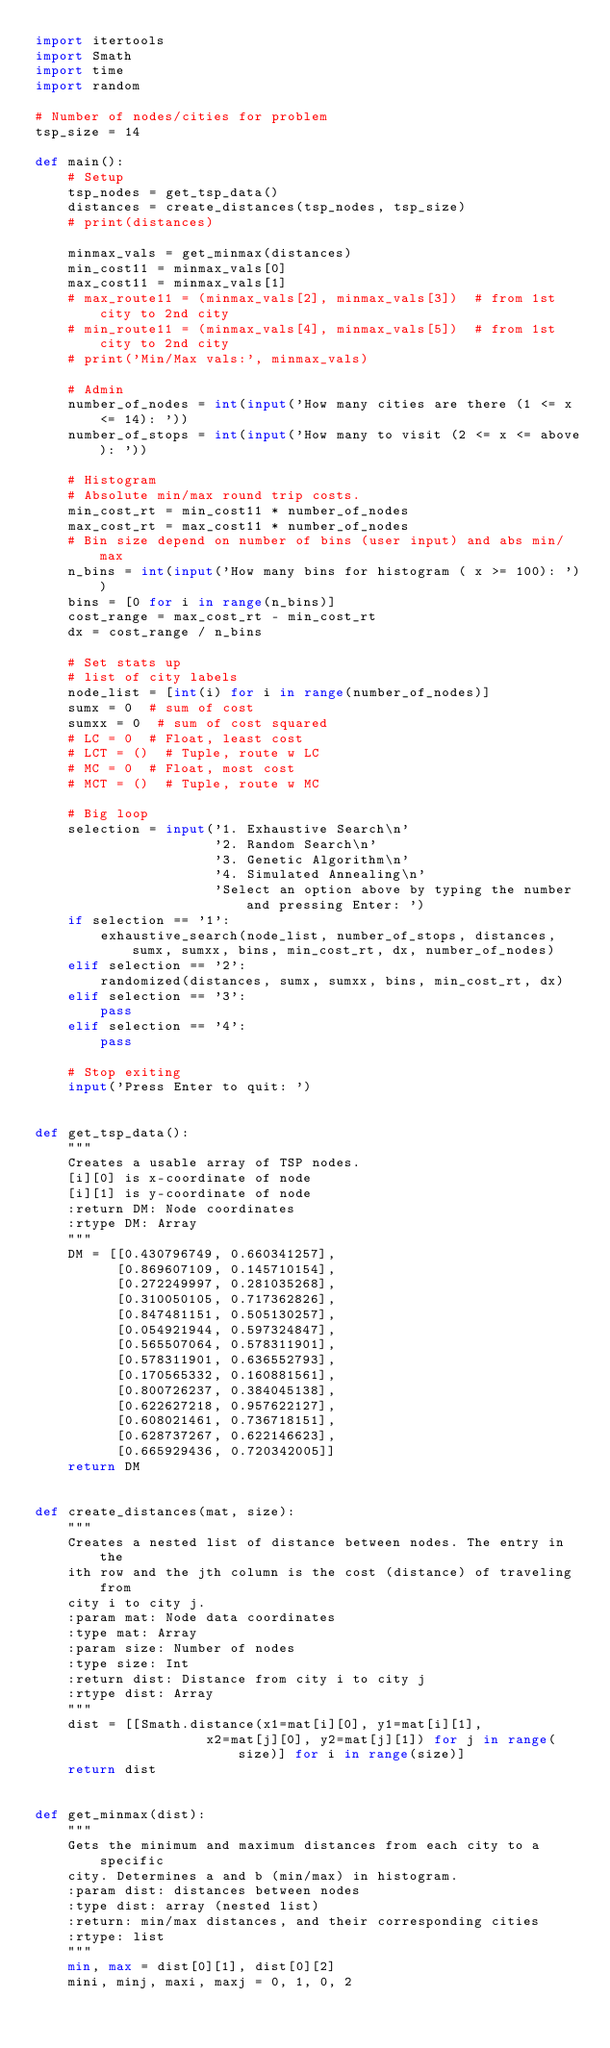Convert code to text. <code><loc_0><loc_0><loc_500><loc_500><_Python_>import itertools
import Smath
import time
import random

# Number of nodes/cities for problem
tsp_size = 14

def main():
    # Setup
    tsp_nodes = get_tsp_data()
    distances = create_distances(tsp_nodes, tsp_size)
    # print(distances)

    minmax_vals = get_minmax(distances)
    min_cost11 = minmax_vals[0]
    max_cost11 = minmax_vals[1]
    # max_route11 = (minmax_vals[2], minmax_vals[3])  # from 1st city to 2nd city
    # min_route11 = (minmax_vals[4], minmax_vals[5])  # from 1st city to 2nd city
    # print('Min/Max vals:', minmax_vals)

    # Admin
    number_of_nodes = int(input('How many cities are there (1 <= x <= 14): '))
    number_of_stops = int(input('How many to visit (2 <= x <= above): '))

    # Histogram
    # Absolute min/max round trip costs.
    min_cost_rt = min_cost11 * number_of_nodes
    max_cost_rt = max_cost11 * number_of_nodes
    # Bin size depend on number of bins (user input) and abs min/max
    n_bins = int(input('How many bins for histogram ( x >= 100): '))
    bins = [0 for i in range(n_bins)]
    cost_range = max_cost_rt - min_cost_rt
    dx = cost_range / n_bins

    # Set stats up
    # list of city labels
    node_list = [int(i) for i in range(number_of_nodes)]
    sumx = 0  # sum of cost
    sumxx = 0  # sum of cost squared
    # LC = 0  # Float, least cost
    # LCT = ()  # Tuple, route w LC
    # MC = 0  # Float, most cost
    # MCT = ()  # Tuple, route w MC

    # Big loop
    selection = input('1. Exhaustive Search\n'
                      '2. Random Search\n'
                      '3. Genetic Algorithm\n'
                      '4. Simulated Annealing\n'
                      'Select an option above by typing the number and pressing Enter: ')
    if selection == '1':
        exhaustive_search(node_list, number_of_stops, distances, sumx, sumxx, bins, min_cost_rt, dx, number_of_nodes)
    elif selection == '2':
        randomized(distances, sumx, sumxx, bins, min_cost_rt, dx)
    elif selection == '3':
        pass
    elif selection == '4':
        pass

    # Stop exiting
    input('Press Enter to quit: ')


def get_tsp_data():
    """
    Creates a usable array of TSP nodes.
    [i][0] is x-coordinate of node
    [i][1] is y-coordinate of node
    :return DM: Node coordinates
    :rtype DM: Array
    """
    DM = [[0.430796749, 0.660341257],
          [0.869607109, 0.145710154],
          [0.272249997, 0.281035268],
          [0.310050105, 0.717362826],
          [0.847481151, 0.505130257],
          [0.054921944, 0.597324847],
          [0.565507064, 0.578311901],
          [0.578311901, 0.636552793],
          [0.170565332, 0.160881561],
          [0.800726237, 0.384045138],
          [0.622627218, 0.957622127],
          [0.608021461, 0.736718151],
          [0.628737267, 0.622146623],
          [0.665929436, 0.720342005]]
    return DM


def create_distances(mat, size):
    """
    Creates a nested list of distance between nodes. The entry in the
    ith row and the jth column is the cost (distance) of traveling from
    city i to city j.
    :param mat: Node data coordinates
    :type mat: Array
    :param size: Number of nodes
    :type size: Int
    :return dist: Distance from city i to city j
    :rtype dist: Array
    """
    dist = [[Smath.distance(x1=mat[i][0], y1=mat[i][1],
                     x2=mat[j][0], y2=mat[j][1]) for j in range(size)] for i in range(size)]
    return dist


def get_minmax(dist):
    """
    Gets the minimum and maximum distances from each city to a specific
    city. Determines a and b (min/max) in histogram.
    :param dist: distances between nodes
    :type dist: array (nested list)
    :return: min/max distances, and their corresponding cities
    :rtype: list
    """
    min, max = dist[0][1], dist[0][2]
    mini, minj, maxi, maxj = 0, 1, 0, 2</code> 